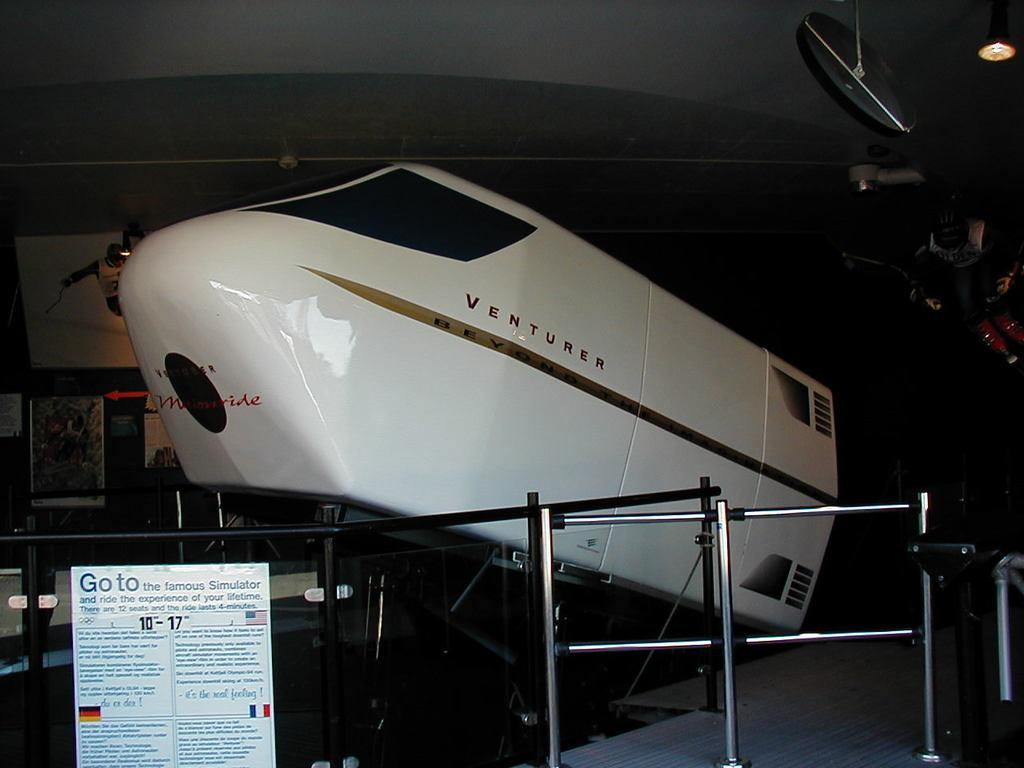<image>
Give a short and clear explanation of the subsequent image. a space simulator named Venturer is on display at a museum 